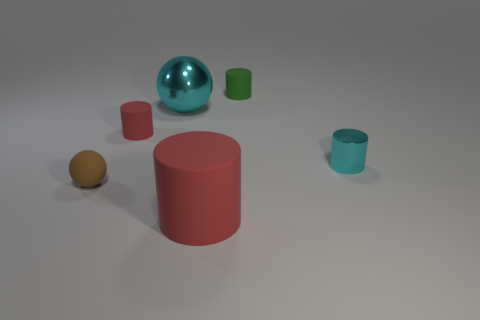Subtract all balls. How many objects are left? 4 Subtract all tiny red cylinders. How many cylinders are left? 3 Subtract 1 spheres. How many spheres are left? 1 Add 6 tiny gray balls. How many tiny gray balls exist? 6 Add 3 small gray balls. How many objects exist? 9 Subtract all cyan cylinders. How many cylinders are left? 3 Subtract 0 red cubes. How many objects are left? 6 Subtract all yellow cylinders. Subtract all red blocks. How many cylinders are left? 4 Subtract all cyan balls. How many brown cylinders are left? 0 Subtract all green metallic cylinders. Subtract all tiny brown spheres. How many objects are left? 5 